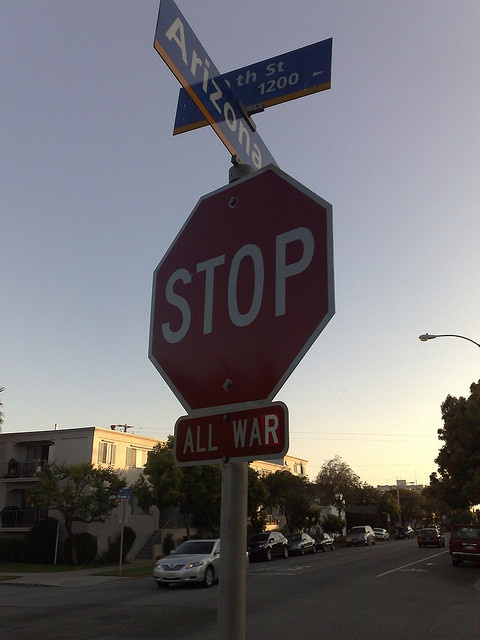Describe the objects in this image and their specific colors. I can see stop sign in gray, black, purple, and darkgray tones, car in gray, black, and purple tones, car in gray and black tones, car in gray and black tones, and car in gray, black, and darkgray tones in this image. 